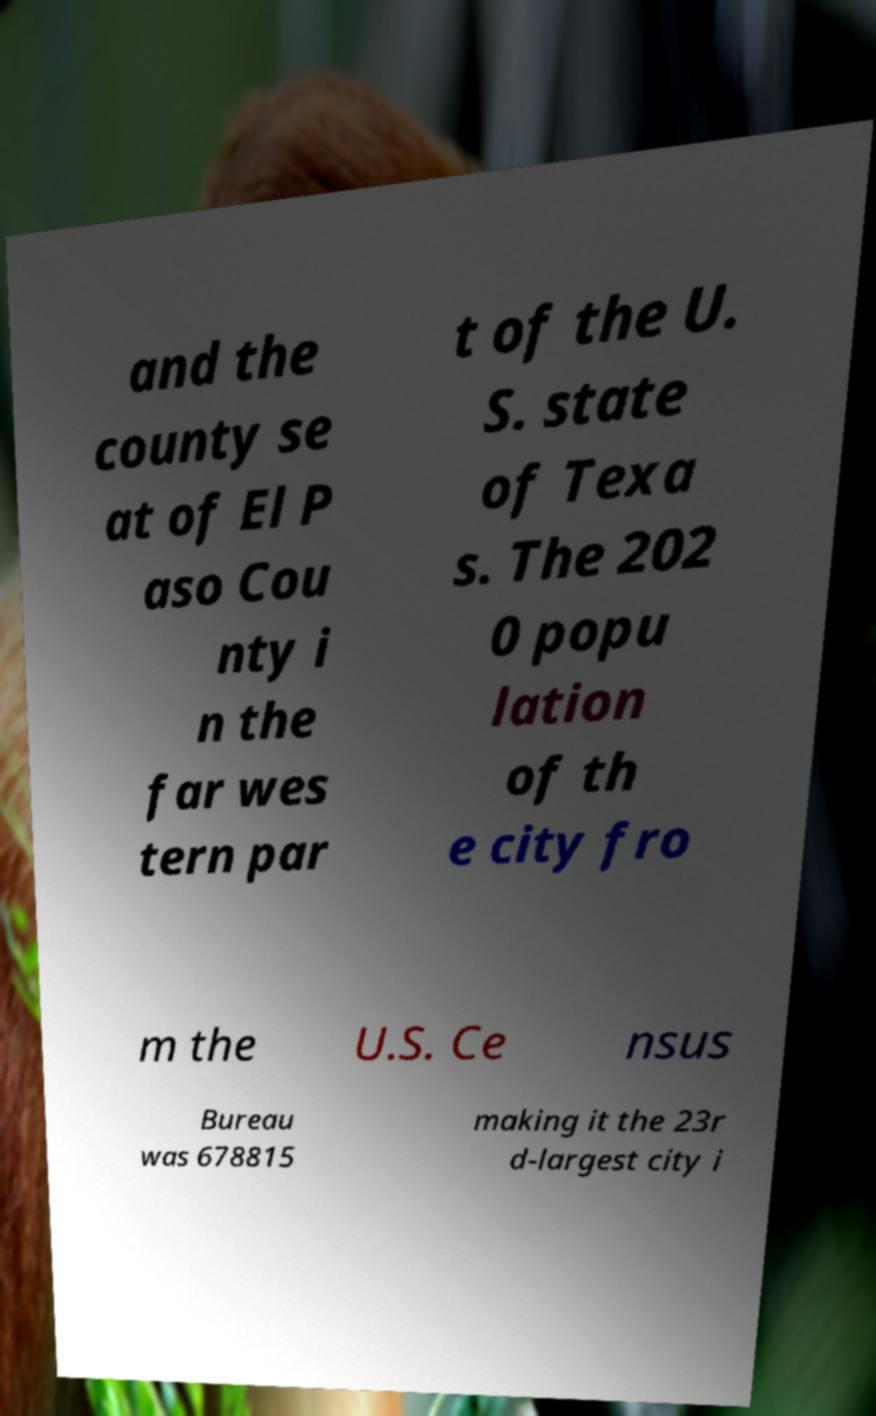Can you read and provide the text displayed in the image?This photo seems to have some interesting text. Can you extract and type it out for me? and the county se at of El P aso Cou nty i n the far wes tern par t of the U. S. state of Texa s. The 202 0 popu lation of th e city fro m the U.S. Ce nsus Bureau was 678815 making it the 23r d-largest city i 